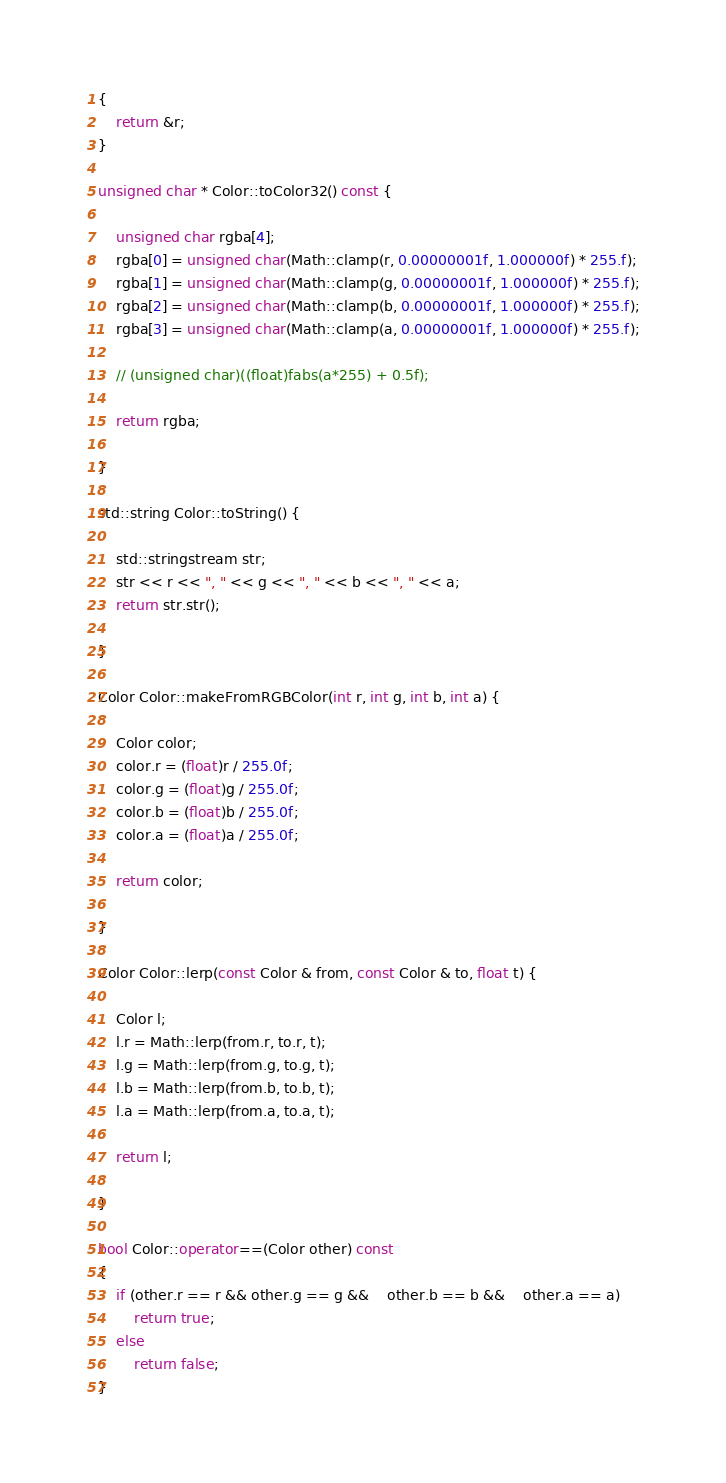Convert code to text. <code><loc_0><loc_0><loc_500><loc_500><_C++_>{
	return &r;
}

unsigned char * Color::toColor32() const {

	unsigned char rgba[4];
	rgba[0] = unsigned char(Math::clamp(r, 0.00000001f, 1.000000f) * 255.f);
	rgba[1] = unsigned char(Math::clamp(g, 0.00000001f, 1.000000f) * 255.f);
	rgba[2] = unsigned char(Math::clamp(b, 0.00000001f, 1.000000f) * 255.f);
	rgba[3] = unsigned char(Math::clamp(a, 0.00000001f, 1.000000f) * 255.f);

	// (unsigned char)((float)fabs(a*255) + 0.5f);

	return rgba;

}

std::string Color::toString() {

	std::stringstream str;
	str << r << ", " << g << ", " << b << ", " << a;
	return str.str();

}

Color Color::makeFromRGBColor(int r, int g, int b, int a) {

	Color color;
	color.r = (float)r / 255.0f;
	color.g = (float)g / 255.0f;
	color.b = (float)b / 255.0f;
	color.a = (float)a / 255.0f;

	return color;

}

Color Color::lerp(const Color & from, const Color & to, float t) {

	Color l;
	l.r = Math::lerp(from.r, to.r, t);
	l.g = Math::lerp(from.g, to.g, t);
	l.b = Math::lerp(from.b, to.b, t);
	l.a = Math::lerp(from.a, to.a, t);

	return l;

}

bool Color::operator==(Color other) const
{
	if (other.r == r && other.g == g &&	other.b == b &&	other.a == a)
		return true;
	else
		return false;
}</code> 